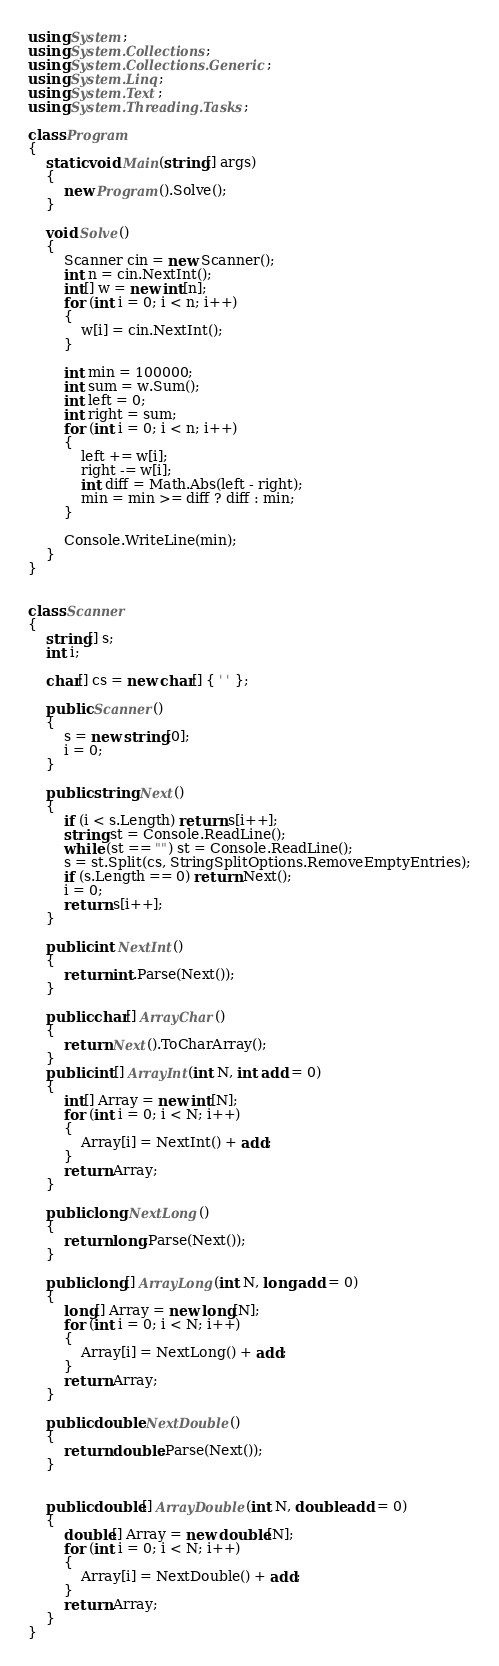Convert code to text. <code><loc_0><loc_0><loc_500><loc_500><_C#_>using System;
using System.Collections;
using System.Collections.Generic;
using System.Linq;
using System.Text;
using System.Threading.Tasks;

class Program
{
    static void Main(string[] args)
    {
        new Program().Solve();
    }

    void Solve()
    {
        Scanner cin = new Scanner();
        int n = cin.NextInt();
        int[] w = new int[n];
        for (int i = 0; i < n; i++)
        {
            w[i] = cin.NextInt();
        }

        int min = 100000;
        int sum = w.Sum();
        int left = 0;
        int right = sum;
        for (int i = 0; i < n; i++)
        {
            left += w[i];
            right -= w[i];
            int diff = Math.Abs(left - right);
            min = min >= diff ? diff : min;
        }

        Console.WriteLine(min);
    }
}


class Scanner
{
    string[] s;
    int i;

    char[] cs = new char[] { ' ' };

    public Scanner()
    {
        s = new string[0];
        i = 0;
    }

    public string Next()
    {
        if (i < s.Length) return s[i++];
        string st = Console.ReadLine();
        while (st == "") st = Console.ReadLine();
        s = st.Split(cs, StringSplitOptions.RemoveEmptyEntries);
        if (s.Length == 0) return Next();
        i = 0;
        return s[i++];
    }

    public int NextInt()
    {
        return int.Parse(Next());
    }

    public char[] ArrayChar()
    {
        return Next().ToCharArray();
    }
    public int[] ArrayInt(int N, int add = 0)
    {
        int[] Array = new int[N];
        for (int i = 0; i < N; i++)
        {
            Array[i] = NextInt() + add;
        }
        return Array;
    }

    public long NextLong()
    {
        return long.Parse(Next());
    }

    public long[] ArrayLong(int N, long add = 0)
    {
        long[] Array = new long[N];
        for (int i = 0; i < N; i++)
        {
            Array[i] = NextLong() + add;
        }
        return Array;
    }

    public double NextDouble()
    {
        return double.Parse(Next());
    }


    public double[] ArrayDouble(int N, double add = 0)
    {
        double[] Array = new double[N];
        for (int i = 0; i < N; i++)
        {
            Array[i] = NextDouble() + add;
        }
        return Array;
    }
}</code> 